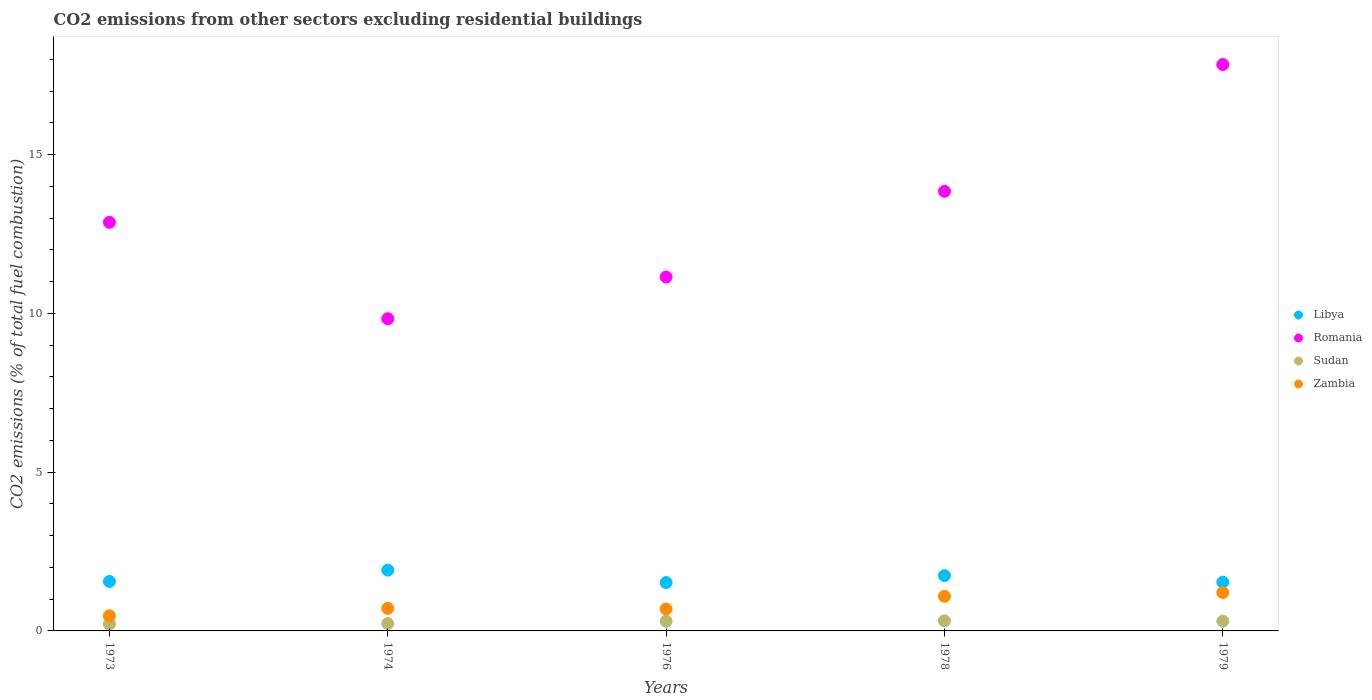What is the total CO2 emitted in Zambia in 1974?
Provide a short and direct response. 0.71. Across all years, what is the maximum total CO2 emitted in Libya?
Keep it short and to the point. 1.91. Across all years, what is the minimum total CO2 emitted in Zambia?
Give a very brief answer. 0.48. In which year was the total CO2 emitted in Romania maximum?
Your response must be concise. 1979. In which year was the total CO2 emitted in Libya minimum?
Your answer should be compact. 1976. What is the total total CO2 emitted in Libya in the graph?
Your answer should be very brief. 8.27. What is the difference between the total CO2 emitted in Romania in 1973 and that in 1978?
Your response must be concise. -0.98. What is the difference between the total CO2 emitted in Zambia in 1978 and the total CO2 emitted in Sudan in 1974?
Keep it short and to the point. 0.86. What is the average total CO2 emitted in Romania per year?
Offer a very short reply. 13.1. In the year 1973, what is the difference between the total CO2 emitted in Libya and total CO2 emitted in Romania?
Give a very brief answer. -11.31. What is the ratio of the total CO2 emitted in Libya in 1976 to that in 1979?
Your answer should be compact. 0.99. Is the difference between the total CO2 emitted in Libya in 1974 and 1976 greater than the difference between the total CO2 emitted in Romania in 1974 and 1976?
Ensure brevity in your answer.  Yes. What is the difference between the highest and the second highest total CO2 emitted in Sudan?
Offer a very short reply. 0.01. What is the difference between the highest and the lowest total CO2 emitted in Zambia?
Your answer should be very brief. 0.73. In how many years, is the total CO2 emitted in Sudan greater than the average total CO2 emitted in Sudan taken over all years?
Your answer should be very brief. 3. Is it the case that in every year, the sum of the total CO2 emitted in Romania and total CO2 emitted in Zambia  is greater than the total CO2 emitted in Libya?
Provide a succinct answer. Yes. Is the total CO2 emitted in Romania strictly greater than the total CO2 emitted in Sudan over the years?
Your answer should be compact. Yes. Are the values on the major ticks of Y-axis written in scientific E-notation?
Provide a short and direct response. No. Does the graph contain grids?
Provide a succinct answer. No. Where does the legend appear in the graph?
Your answer should be very brief. Center right. How are the legend labels stacked?
Give a very brief answer. Vertical. What is the title of the graph?
Keep it short and to the point. CO2 emissions from other sectors excluding residential buildings. Does "Jordan" appear as one of the legend labels in the graph?
Your answer should be very brief. No. What is the label or title of the X-axis?
Offer a very short reply. Years. What is the label or title of the Y-axis?
Your answer should be very brief. CO2 emissions (% of total fuel combustion). What is the CO2 emissions (% of total fuel combustion) in Libya in 1973?
Your response must be concise. 1.56. What is the CO2 emissions (% of total fuel combustion) in Romania in 1973?
Offer a terse response. 12.87. What is the CO2 emissions (% of total fuel combustion) of Sudan in 1973?
Offer a very short reply. 0.22. What is the CO2 emissions (% of total fuel combustion) in Zambia in 1973?
Your answer should be compact. 0.48. What is the CO2 emissions (% of total fuel combustion) of Libya in 1974?
Give a very brief answer. 1.91. What is the CO2 emissions (% of total fuel combustion) in Romania in 1974?
Your answer should be very brief. 9.83. What is the CO2 emissions (% of total fuel combustion) of Sudan in 1974?
Your answer should be compact. 0.23. What is the CO2 emissions (% of total fuel combustion) of Zambia in 1974?
Provide a succinct answer. 0.71. What is the CO2 emissions (% of total fuel combustion) in Libya in 1976?
Provide a succinct answer. 1.52. What is the CO2 emissions (% of total fuel combustion) of Romania in 1976?
Your response must be concise. 11.14. What is the CO2 emissions (% of total fuel combustion) of Sudan in 1976?
Keep it short and to the point. 0.3. What is the CO2 emissions (% of total fuel combustion) in Zambia in 1976?
Provide a short and direct response. 0.69. What is the CO2 emissions (% of total fuel combustion) of Libya in 1978?
Make the answer very short. 1.74. What is the CO2 emissions (% of total fuel combustion) in Romania in 1978?
Keep it short and to the point. 13.84. What is the CO2 emissions (% of total fuel combustion) in Sudan in 1978?
Make the answer very short. 0.32. What is the CO2 emissions (% of total fuel combustion) in Zambia in 1978?
Provide a short and direct response. 1.09. What is the CO2 emissions (% of total fuel combustion) in Libya in 1979?
Give a very brief answer. 1.54. What is the CO2 emissions (% of total fuel combustion) of Romania in 1979?
Your answer should be very brief. 17.83. What is the CO2 emissions (% of total fuel combustion) of Sudan in 1979?
Your response must be concise. 0.31. What is the CO2 emissions (% of total fuel combustion) in Zambia in 1979?
Offer a terse response. 1.21. Across all years, what is the maximum CO2 emissions (% of total fuel combustion) in Libya?
Your answer should be very brief. 1.91. Across all years, what is the maximum CO2 emissions (% of total fuel combustion) in Romania?
Provide a succinct answer. 17.83. Across all years, what is the maximum CO2 emissions (% of total fuel combustion) of Sudan?
Your answer should be very brief. 0.32. Across all years, what is the maximum CO2 emissions (% of total fuel combustion) in Zambia?
Offer a very short reply. 1.21. Across all years, what is the minimum CO2 emissions (% of total fuel combustion) in Libya?
Your answer should be very brief. 1.52. Across all years, what is the minimum CO2 emissions (% of total fuel combustion) in Romania?
Keep it short and to the point. 9.83. Across all years, what is the minimum CO2 emissions (% of total fuel combustion) of Sudan?
Give a very brief answer. 0.22. Across all years, what is the minimum CO2 emissions (% of total fuel combustion) of Zambia?
Make the answer very short. 0.48. What is the total CO2 emissions (% of total fuel combustion) of Libya in the graph?
Give a very brief answer. 8.27. What is the total CO2 emissions (% of total fuel combustion) in Romania in the graph?
Your response must be concise. 65.52. What is the total CO2 emissions (% of total fuel combustion) in Sudan in the graph?
Provide a succinct answer. 1.38. What is the total CO2 emissions (% of total fuel combustion) of Zambia in the graph?
Offer a very short reply. 4.18. What is the difference between the CO2 emissions (% of total fuel combustion) in Libya in 1973 and that in 1974?
Your response must be concise. -0.36. What is the difference between the CO2 emissions (% of total fuel combustion) in Romania in 1973 and that in 1974?
Make the answer very short. 3.03. What is the difference between the CO2 emissions (% of total fuel combustion) in Sudan in 1973 and that in 1974?
Your response must be concise. -0.01. What is the difference between the CO2 emissions (% of total fuel combustion) in Zambia in 1973 and that in 1974?
Make the answer very short. -0.23. What is the difference between the CO2 emissions (% of total fuel combustion) of Libya in 1973 and that in 1976?
Provide a succinct answer. 0.04. What is the difference between the CO2 emissions (% of total fuel combustion) of Romania in 1973 and that in 1976?
Provide a short and direct response. 1.72. What is the difference between the CO2 emissions (% of total fuel combustion) in Sudan in 1973 and that in 1976?
Provide a succinct answer. -0.09. What is the difference between the CO2 emissions (% of total fuel combustion) of Zambia in 1973 and that in 1976?
Offer a very short reply. -0.21. What is the difference between the CO2 emissions (% of total fuel combustion) of Libya in 1973 and that in 1978?
Provide a short and direct response. -0.18. What is the difference between the CO2 emissions (% of total fuel combustion) in Romania in 1973 and that in 1978?
Give a very brief answer. -0.98. What is the difference between the CO2 emissions (% of total fuel combustion) in Sudan in 1973 and that in 1978?
Provide a short and direct response. -0.1. What is the difference between the CO2 emissions (% of total fuel combustion) of Zambia in 1973 and that in 1978?
Your answer should be compact. -0.61. What is the difference between the CO2 emissions (% of total fuel combustion) of Libya in 1973 and that in 1979?
Ensure brevity in your answer.  0.02. What is the difference between the CO2 emissions (% of total fuel combustion) of Romania in 1973 and that in 1979?
Give a very brief answer. -4.97. What is the difference between the CO2 emissions (% of total fuel combustion) in Sudan in 1973 and that in 1979?
Your answer should be very brief. -0.09. What is the difference between the CO2 emissions (% of total fuel combustion) of Zambia in 1973 and that in 1979?
Offer a terse response. -0.73. What is the difference between the CO2 emissions (% of total fuel combustion) of Libya in 1974 and that in 1976?
Your answer should be compact. 0.39. What is the difference between the CO2 emissions (% of total fuel combustion) of Romania in 1974 and that in 1976?
Keep it short and to the point. -1.31. What is the difference between the CO2 emissions (% of total fuel combustion) in Sudan in 1974 and that in 1976?
Offer a very short reply. -0.07. What is the difference between the CO2 emissions (% of total fuel combustion) of Zambia in 1974 and that in 1976?
Your response must be concise. 0.02. What is the difference between the CO2 emissions (% of total fuel combustion) of Libya in 1974 and that in 1978?
Provide a succinct answer. 0.17. What is the difference between the CO2 emissions (% of total fuel combustion) of Romania in 1974 and that in 1978?
Your response must be concise. -4.01. What is the difference between the CO2 emissions (% of total fuel combustion) of Sudan in 1974 and that in 1978?
Ensure brevity in your answer.  -0.09. What is the difference between the CO2 emissions (% of total fuel combustion) in Zambia in 1974 and that in 1978?
Your response must be concise. -0.38. What is the difference between the CO2 emissions (% of total fuel combustion) of Libya in 1974 and that in 1979?
Provide a succinct answer. 0.38. What is the difference between the CO2 emissions (% of total fuel combustion) in Romania in 1974 and that in 1979?
Your answer should be very brief. -8. What is the difference between the CO2 emissions (% of total fuel combustion) in Sudan in 1974 and that in 1979?
Give a very brief answer. -0.08. What is the difference between the CO2 emissions (% of total fuel combustion) in Zambia in 1974 and that in 1979?
Your response must be concise. -0.5. What is the difference between the CO2 emissions (% of total fuel combustion) in Libya in 1976 and that in 1978?
Offer a very short reply. -0.22. What is the difference between the CO2 emissions (% of total fuel combustion) of Romania in 1976 and that in 1978?
Offer a very short reply. -2.7. What is the difference between the CO2 emissions (% of total fuel combustion) of Sudan in 1976 and that in 1978?
Offer a very short reply. -0.01. What is the difference between the CO2 emissions (% of total fuel combustion) of Zambia in 1976 and that in 1978?
Your answer should be very brief. -0.4. What is the difference between the CO2 emissions (% of total fuel combustion) of Libya in 1976 and that in 1979?
Give a very brief answer. -0.01. What is the difference between the CO2 emissions (% of total fuel combustion) of Romania in 1976 and that in 1979?
Offer a very short reply. -6.69. What is the difference between the CO2 emissions (% of total fuel combustion) in Sudan in 1976 and that in 1979?
Offer a terse response. -0. What is the difference between the CO2 emissions (% of total fuel combustion) in Zambia in 1976 and that in 1979?
Your answer should be compact. -0.52. What is the difference between the CO2 emissions (% of total fuel combustion) in Libya in 1978 and that in 1979?
Keep it short and to the point. 0.21. What is the difference between the CO2 emissions (% of total fuel combustion) of Romania in 1978 and that in 1979?
Offer a terse response. -3.99. What is the difference between the CO2 emissions (% of total fuel combustion) of Sudan in 1978 and that in 1979?
Ensure brevity in your answer.  0.01. What is the difference between the CO2 emissions (% of total fuel combustion) of Zambia in 1978 and that in 1979?
Keep it short and to the point. -0.12. What is the difference between the CO2 emissions (% of total fuel combustion) of Libya in 1973 and the CO2 emissions (% of total fuel combustion) of Romania in 1974?
Make the answer very short. -8.27. What is the difference between the CO2 emissions (% of total fuel combustion) of Libya in 1973 and the CO2 emissions (% of total fuel combustion) of Sudan in 1974?
Ensure brevity in your answer.  1.33. What is the difference between the CO2 emissions (% of total fuel combustion) of Libya in 1973 and the CO2 emissions (% of total fuel combustion) of Zambia in 1974?
Your answer should be compact. 0.85. What is the difference between the CO2 emissions (% of total fuel combustion) of Romania in 1973 and the CO2 emissions (% of total fuel combustion) of Sudan in 1974?
Offer a very short reply. 12.63. What is the difference between the CO2 emissions (% of total fuel combustion) of Romania in 1973 and the CO2 emissions (% of total fuel combustion) of Zambia in 1974?
Give a very brief answer. 12.15. What is the difference between the CO2 emissions (% of total fuel combustion) in Sudan in 1973 and the CO2 emissions (% of total fuel combustion) in Zambia in 1974?
Offer a very short reply. -0.49. What is the difference between the CO2 emissions (% of total fuel combustion) in Libya in 1973 and the CO2 emissions (% of total fuel combustion) in Romania in 1976?
Your answer should be compact. -9.59. What is the difference between the CO2 emissions (% of total fuel combustion) of Libya in 1973 and the CO2 emissions (% of total fuel combustion) of Sudan in 1976?
Keep it short and to the point. 1.25. What is the difference between the CO2 emissions (% of total fuel combustion) of Libya in 1973 and the CO2 emissions (% of total fuel combustion) of Zambia in 1976?
Your answer should be very brief. 0.87. What is the difference between the CO2 emissions (% of total fuel combustion) in Romania in 1973 and the CO2 emissions (% of total fuel combustion) in Sudan in 1976?
Provide a short and direct response. 12.56. What is the difference between the CO2 emissions (% of total fuel combustion) of Romania in 1973 and the CO2 emissions (% of total fuel combustion) of Zambia in 1976?
Give a very brief answer. 12.18. What is the difference between the CO2 emissions (% of total fuel combustion) of Sudan in 1973 and the CO2 emissions (% of total fuel combustion) of Zambia in 1976?
Offer a terse response. -0.47. What is the difference between the CO2 emissions (% of total fuel combustion) in Libya in 1973 and the CO2 emissions (% of total fuel combustion) in Romania in 1978?
Your answer should be very brief. -12.29. What is the difference between the CO2 emissions (% of total fuel combustion) of Libya in 1973 and the CO2 emissions (% of total fuel combustion) of Sudan in 1978?
Provide a succinct answer. 1.24. What is the difference between the CO2 emissions (% of total fuel combustion) in Libya in 1973 and the CO2 emissions (% of total fuel combustion) in Zambia in 1978?
Give a very brief answer. 0.47. What is the difference between the CO2 emissions (% of total fuel combustion) of Romania in 1973 and the CO2 emissions (% of total fuel combustion) of Sudan in 1978?
Your answer should be compact. 12.55. What is the difference between the CO2 emissions (% of total fuel combustion) in Romania in 1973 and the CO2 emissions (% of total fuel combustion) in Zambia in 1978?
Give a very brief answer. 11.78. What is the difference between the CO2 emissions (% of total fuel combustion) of Sudan in 1973 and the CO2 emissions (% of total fuel combustion) of Zambia in 1978?
Offer a terse response. -0.87. What is the difference between the CO2 emissions (% of total fuel combustion) in Libya in 1973 and the CO2 emissions (% of total fuel combustion) in Romania in 1979?
Offer a very short reply. -16.28. What is the difference between the CO2 emissions (% of total fuel combustion) of Libya in 1973 and the CO2 emissions (% of total fuel combustion) of Sudan in 1979?
Give a very brief answer. 1.25. What is the difference between the CO2 emissions (% of total fuel combustion) in Libya in 1973 and the CO2 emissions (% of total fuel combustion) in Zambia in 1979?
Your answer should be compact. 0.35. What is the difference between the CO2 emissions (% of total fuel combustion) of Romania in 1973 and the CO2 emissions (% of total fuel combustion) of Sudan in 1979?
Offer a terse response. 12.56. What is the difference between the CO2 emissions (% of total fuel combustion) in Romania in 1973 and the CO2 emissions (% of total fuel combustion) in Zambia in 1979?
Keep it short and to the point. 11.66. What is the difference between the CO2 emissions (% of total fuel combustion) of Sudan in 1973 and the CO2 emissions (% of total fuel combustion) of Zambia in 1979?
Provide a short and direct response. -0.99. What is the difference between the CO2 emissions (% of total fuel combustion) of Libya in 1974 and the CO2 emissions (% of total fuel combustion) of Romania in 1976?
Your answer should be very brief. -9.23. What is the difference between the CO2 emissions (% of total fuel combustion) in Libya in 1974 and the CO2 emissions (% of total fuel combustion) in Sudan in 1976?
Make the answer very short. 1.61. What is the difference between the CO2 emissions (% of total fuel combustion) of Libya in 1974 and the CO2 emissions (% of total fuel combustion) of Zambia in 1976?
Provide a short and direct response. 1.22. What is the difference between the CO2 emissions (% of total fuel combustion) in Romania in 1974 and the CO2 emissions (% of total fuel combustion) in Sudan in 1976?
Make the answer very short. 9.53. What is the difference between the CO2 emissions (% of total fuel combustion) in Romania in 1974 and the CO2 emissions (% of total fuel combustion) in Zambia in 1976?
Make the answer very short. 9.14. What is the difference between the CO2 emissions (% of total fuel combustion) in Sudan in 1974 and the CO2 emissions (% of total fuel combustion) in Zambia in 1976?
Provide a succinct answer. -0.46. What is the difference between the CO2 emissions (% of total fuel combustion) in Libya in 1974 and the CO2 emissions (% of total fuel combustion) in Romania in 1978?
Provide a succinct answer. -11.93. What is the difference between the CO2 emissions (% of total fuel combustion) of Libya in 1974 and the CO2 emissions (% of total fuel combustion) of Sudan in 1978?
Your response must be concise. 1.6. What is the difference between the CO2 emissions (% of total fuel combustion) in Libya in 1974 and the CO2 emissions (% of total fuel combustion) in Zambia in 1978?
Provide a short and direct response. 0.82. What is the difference between the CO2 emissions (% of total fuel combustion) in Romania in 1974 and the CO2 emissions (% of total fuel combustion) in Sudan in 1978?
Make the answer very short. 9.51. What is the difference between the CO2 emissions (% of total fuel combustion) in Romania in 1974 and the CO2 emissions (% of total fuel combustion) in Zambia in 1978?
Provide a short and direct response. 8.74. What is the difference between the CO2 emissions (% of total fuel combustion) in Sudan in 1974 and the CO2 emissions (% of total fuel combustion) in Zambia in 1978?
Give a very brief answer. -0.86. What is the difference between the CO2 emissions (% of total fuel combustion) of Libya in 1974 and the CO2 emissions (% of total fuel combustion) of Romania in 1979?
Your answer should be very brief. -15.92. What is the difference between the CO2 emissions (% of total fuel combustion) in Libya in 1974 and the CO2 emissions (% of total fuel combustion) in Sudan in 1979?
Give a very brief answer. 1.61. What is the difference between the CO2 emissions (% of total fuel combustion) in Libya in 1974 and the CO2 emissions (% of total fuel combustion) in Zambia in 1979?
Your response must be concise. 0.71. What is the difference between the CO2 emissions (% of total fuel combustion) of Romania in 1974 and the CO2 emissions (% of total fuel combustion) of Sudan in 1979?
Ensure brevity in your answer.  9.52. What is the difference between the CO2 emissions (% of total fuel combustion) of Romania in 1974 and the CO2 emissions (% of total fuel combustion) of Zambia in 1979?
Keep it short and to the point. 8.62. What is the difference between the CO2 emissions (% of total fuel combustion) of Sudan in 1974 and the CO2 emissions (% of total fuel combustion) of Zambia in 1979?
Your answer should be compact. -0.98. What is the difference between the CO2 emissions (% of total fuel combustion) of Libya in 1976 and the CO2 emissions (% of total fuel combustion) of Romania in 1978?
Give a very brief answer. -12.32. What is the difference between the CO2 emissions (% of total fuel combustion) of Libya in 1976 and the CO2 emissions (% of total fuel combustion) of Sudan in 1978?
Your response must be concise. 1.21. What is the difference between the CO2 emissions (% of total fuel combustion) in Libya in 1976 and the CO2 emissions (% of total fuel combustion) in Zambia in 1978?
Give a very brief answer. 0.43. What is the difference between the CO2 emissions (% of total fuel combustion) of Romania in 1976 and the CO2 emissions (% of total fuel combustion) of Sudan in 1978?
Provide a short and direct response. 10.83. What is the difference between the CO2 emissions (% of total fuel combustion) of Romania in 1976 and the CO2 emissions (% of total fuel combustion) of Zambia in 1978?
Ensure brevity in your answer.  10.05. What is the difference between the CO2 emissions (% of total fuel combustion) in Sudan in 1976 and the CO2 emissions (% of total fuel combustion) in Zambia in 1978?
Provide a short and direct response. -0.79. What is the difference between the CO2 emissions (% of total fuel combustion) of Libya in 1976 and the CO2 emissions (% of total fuel combustion) of Romania in 1979?
Provide a short and direct response. -16.31. What is the difference between the CO2 emissions (% of total fuel combustion) in Libya in 1976 and the CO2 emissions (% of total fuel combustion) in Sudan in 1979?
Give a very brief answer. 1.21. What is the difference between the CO2 emissions (% of total fuel combustion) of Libya in 1976 and the CO2 emissions (% of total fuel combustion) of Zambia in 1979?
Give a very brief answer. 0.31. What is the difference between the CO2 emissions (% of total fuel combustion) of Romania in 1976 and the CO2 emissions (% of total fuel combustion) of Sudan in 1979?
Ensure brevity in your answer.  10.84. What is the difference between the CO2 emissions (% of total fuel combustion) of Romania in 1976 and the CO2 emissions (% of total fuel combustion) of Zambia in 1979?
Your response must be concise. 9.94. What is the difference between the CO2 emissions (% of total fuel combustion) of Sudan in 1976 and the CO2 emissions (% of total fuel combustion) of Zambia in 1979?
Your response must be concise. -0.9. What is the difference between the CO2 emissions (% of total fuel combustion) in Libya in 1978 and the CO2 emissions (% of total fuel combustion) in Romania in 1979?
Ensure brevity in your answer.  -16.09. What is the difference between the CO2 emissions (% of total fuel combustion) in Libya in 1978 and the CO2 emissions (% of total fuel combustion) in Sudan in 1979?
Your answer should be very brief. 1.43. What is the difference between the CO2 emissions (% of total fuel combustion) of Libya in 1978 and the CO2 emissions (% of total fuel combustion) of Zambia in 1979?
Your response must be concise. 0.53. What is the difference between the CO2 emissions (% of total fuel combustion) of Romania in 1978 and the CO2 emissions (% of total fuel combustion) of Sudan in 1979?
Make the answer very short. 13.53. What is the difference between the CO2 emissions (% of total fuel combustion) in Romania in 1978 and the CO2 emissions (% of total fuel combustion) in Zambia in 1979?
Ensure brevity in your answer.  12.63. What is the difference between the CO2 emissions (% of total fuel combustion) in Sudan in 1978 and the CO2 emissions (% of total fuel combustion) in Zambia in 1979?
Offer a terse response. -0.89. What is the average CO2 emissions (% of total fuel combustion) of Libya per year?
Your answer should be very brief. 1.65. What is the average CO2 emissions (% of total fuel combustion) in Romania per year?
Provide a short and direct response. 13.1. What is the average CO2 emissions (% of total fuel combustion) of Sudan per year?
Ensure brevity in your answer.  0.28. What is the average CO2 emissions (% of total fuel combustion) in Zambia per year?
Provide a succinct answer. 0.84. In the year 1973, what is the difference between the CO2 emissions (% of total fuel combustion) of Libya and CO2 emissions (% of total fuel combustion) of Romania?
Your response must be concise. -11.31. In the year 1973, what is the difference between the CO2 emissions (% of total fuel combustion) in Libya and CO2 emissions (% of total fuel combustion) in Sudan?
Provide a succinct answer. 1.34. In the year 1973, what is the difference between the CO2 emissions (% of total fuel combustion) of Libya and CO2 emissions (% of total fuel combustion) of Zambia?
Your answer should be very brief. 1.08. In the year 1973, what is the difference between the CO2 emissions (% of total fuel combustion) of Romania and CO2 emissions (% of total fuel combustion) of Sudan?
Keep it short and to the point. 12.65. In the year 1973, what is the difference between the CO2 emissions (% of total fuel combustion) of Romania and CO2 emissions (% of total fuel combustion) of Zambia?
Give a very brief answer. 12.39. In the year 1973, what is the difference between the CO2 emissions (% of total fuel combustion) of Sudan and CO2 emissions (% of total fuel combustion) of Zambia?
Your response must be concise. -0.26. In the year 1974, what is the difference between the CO2 emissions (% of total fuel combustion) of Libya and CO2 emissions (% of total fuel combustion) of Romania?
Your response must be concise. -7.92. In the year 1974, what is the difference between the CO2 emissions (% of total fuel combustion) of Libya and CO2 emissions (% of total fuel combustion) of Sudan?
Keep it short and to the point. 1.68. In the year 1974, what is the difference between the CO2 emissions (% of total fuel combustion) of Libya and CO2 emissions (% of total fuel combustion) of Zambia?
Your answer should be very brief. 1.2. In the year 1974, what is the difference between the CO2 emissions (% of total fuel combustion) in Romania and CO2 emissions (% of total fuel combustion) in Sudan?
Offer a terse response. 9.6. In the year 1974, what is the difference between the CO2 emissions (% of total fuel combustion) of Romania and CO2 emissions (% of total fuel combustion) of Zambia?
Ensure brevity in your answer.  9.12. In the year 1974, what is the difference between the CO2 emissions (% of total fuel combustion) of Sudan and CO2 emissions (% of total fuel combustion) of Zambia?
Offer a very short reply. -0.48. In the year 1976, what is the difference between the CO2 emissions (% of total fuel combustion) in Libya and CO2 emissions (% of total fuel combustion) in Romania?
Provide a short and direct response. -9.62. In the year 1976, what is the difference between the CO2 emissions (% of total fuel combustion) in Libya and CO2 emissions (% of total fuel combustion) in Sudan?
Provide a succinct answer. 1.22. In the year 1976, what is the difference between the CO2 emissions (% of total fuel combustion) in Libya and CO2 emissions (% of total fuel combustion) in Zambia?
Make the answer very short. 0.83. In the year 1976, what is the difference between the CO2 emissions (% of total fuel combustion) in Romania and CO2 emissions (% of total fuel combustion) in Sudan?
Your answer should be compact. 10.84. In the year 1976, what is the difference between the CO2 emissions (% of total fuel combustion) in Romania and CO2 emissions (% of total fuel combustion) in Zambia?
Offer a very short reply. 10.45. In the year 1976, what is the difference between the CO2 emissions (% of total fuel combustion) in Sudan and CO2 emissions (% of total fuel combustion) in Zambia?
Offer a terse response. -0.38. In the year 1978, what is the difference between the CO2 emissions (% of total fuel combustion) of Libya and CO2 emissions (% of total fuel combustion) of Romania?
Provide a succinct answer. -12.1. In the year 1978, what is the difference between the CO2 emissions (% of total fuel combustion) of Libya and CO2 emissions (% of total fuel combustion) of Sudan?
Your response must be concise. 1.42. In the year 1978, what is the difference between the CO2 emissions (% of total fuel combustion) in Libya and CO2 emissions (% of total fuel combustion) in Zambia?
Ensure brevity in your answer.  0.65. In the year 1978, what is the difference between the CO2 emissions (% of total fuel combustion) of Romania and CO2 emissions (% of total fuel combustion) of Sudan?
Your answer should be very brief. 13.53. In the year 1978, what is the difference between the CO2 emissions (% of total fuel combustion) in Romania and CO2 emissions (% of total fuel combustion) in Zambia?
Ensure brevity in your answer.  12.75. In the year 1978, what is the difference between the CO2 emissions (% of total fuel combustion) of Sudan and CO2 emissions (% of total fuel combustion) of Zambia?
Offer a terse response. -0.77. In the year 1979, what is the difference between the CO2 emissions (% of total fuel combustion) in Libya and CO2 emissions (% of total fuel combustion) in Romania?
Provide a succinct answer. -16.3. In the year 1979, what is the difference between the CO2 emissions (% of total fuel combustion) of Libya and CO2 emissions (% of total fuel combustion) of Sudan?
Provide a succinct answer. 1.23. In the year 1979, what is the difference between the CO2 emissions (% of total fuel combustion) of Libya and CO2 emissions (% of total fuel combustion) of Zambia?
Your response must be concise. 0.33. In the year 1979, what is the difference between the CO2 emissions (% of total fuel combustion) of Romania and CO2 emissions (% of total fuel combustion) of Sudan?
Offer a very short reply. 17.53. In the year 1979, what is the difference between the CO2 emissions (% of total fuel combustion) in Romania and CO2 emissions (% of total fuel combustion) in Zambia?
Your response must be concise. 16.63. In the year 1979, what is the difference between the CO2 emissions (% of total fuel combustion) of Sudan and CO2 emissions (% of total fuel combustion) of Zambia?
Ensure brevity in your answer.  -0.9. What is the ratio of the CO2 emissions (% of total fuel combustion) in Libya in 1973 to that in 1974?
Offer a terse response. 0.81. What is the ratio of the CO2 emissions (% of total fuel combustion) of Romania in 1973 to that in 1974?
Your answer should be very brief. 1.31. What is the ratio of the CO2 emissions (% of total fuel combustion) in Sudan in 1973 to that in 1974?
Provide a succinct answer. 0.94. What is the ratio of the CO2 emissions (% of total fuel combustion) in Zambia in 1973 to that in 1974?
Provide a short and direct response. 0.67. What is the ratio of the CO2 emissions (% of total fuel combustion) of Libya in 1973 to that in 1976?
Offer a very short reply. 1.02. What is the ratio of the CO2 emissions (% of total fuel combustion) of Romania in 1973 to that in 1976?
Provide a succinct answer. 1.15. What is the ratio of the CO2 emissions (% of total fuel combustion) in Sudan in 1973 to that in 1976?
Provide a short and direct response. 0.71. What is the ratio of the CO2 emissions (% of total fuel combustion) of Zambia in 1973 to that in 1976?
Make the answer very short. 0.69. What is the ratio of the CO2 emissions (% of total fuel combustion) of Libya in 1973 to that in 1978?
Give a very brief answer. 0.89. What is the ratio of the CO2 emissions (% of total fuel combustion) in Romania in 1973 to that in 1978?
Provide a succinct answer. 0.93. What is the ratio of the CO2 emissions (% of total fuel combustion) in Sudan in 1973 to that in 1978?
Your answer should be very brief. 0.69. What is the ratio of the CO2 emissions (% of total fuel combustion) in Zambia in 1973 to that in 1978?
Give a very brief answer. 0.44. What is the ratio of the CO2 emissions (% of total fuel combustion) in Libya in 1973 to that in 1979?
Offer a terse response. 1.01. What is the ratio of the CO2 emissions (% of total fuel combustion) of Romania in 1973 to that in 1979?
Offer a very short reply. 0.72. What is the ratio of the CO2 emissions (% of total fuel combustion) of Sudan in 1973 to that in 1979?
Your response must be concise. 0.7. What is the ratio of the CO2 emissions (% of total fuel combustion) of Zambia in 1973 to that in 1979?
Keep it short and to the point. 0.4. What is the ratio of the CO2 emissions (% of total fuel combustion) in Libya in 1974 to that in 1976?
Offer a very short reply. 1.26. What is the ratio of the CO2 emissions (% of total fuel combustion) of Romania in 1974 to that in 1976?
Give a very brief answer. 0.88. What is the ratio of the CO2 emissions (% of total fuel combustion) in Sudan in 1974 to that in 1976?
Keep it short and to the point. 0.76. What is the ratio of the CO2 emissions (% of total fuel combustion) in Zambia in 1974 to that in 1976?
Offer a terse response. 1.03. What is the ratio of the CO2 emissions (% of total fuel combustion) of Libya in 1974 to that in 1978?
Your answer should be compact. 1.1. What is the ratio of the CO2 emissions (% of total fuel combustion) of Romania in 1974 to that in 1978?
Your response must be concise. 0.71. What is the ratio of the CO2 emissions (% of total fuel combustion) of Sudan in 1974 to that in 1978?
Your answer should be very brief. 0.73. What is the ratio of the CO2 emissions (% of total fuel combustion) in Zambia in 1974 to that in 1978?
Offer a terse response. 0.65. What is the ratio of the CO2 emissions (% of total fuel combustion) of Libya in 1974 to that in 1979?
Your answer should be compact. 1.25. What is the ratio of the CO2 emissions (% of total fuel combustion) of Romania in 1974 to that in 1979?
Give a very brief answer. 0.55. What is the ratio of the CO2 emissions (% of total fuel combustion) of Sudan in 1974 to that in 1979?
Keep it short and to the point. 0.75. What is the ratio of the CO2 emissions (% of total fuel combustion) of Zambia in 1974 to that in 1979?
Offer a terse response. 0.59. What is the ratio of the CO2 emissions (% of total fuel combustion) in Libya in 1976 to that in 1978?
Offer a very short reply. 0.87. What is the ratio of the CO2 emissions (% of total fuel combustion) in Romania in 1976 to that in 1978?
Offer a terse response. 0.81. What is the ratio of the CO2 emissions (% of total fuel combustion) in Sudan in 1976 to that in 1978?
Your response must be concise. 0.96. What is the ratio of the CO2 emissions (% of total fuel combustion) of Zambia in 1976 to that in 1978?
Provide a short and direct response. 0.63. What is the ratio of the CO2 emissions (% of total fuel combustion) of Romania in 1976 to that in 1979?
Offer a very short reply. 0.62. What is the ratio of the CO2 emissions (% of total fuel combustion) in Zambia in 1976 to that in 1979?
Provide a succinct answer. 0.57. What is the ratio of the CO2 emissions (% of total fuel combustion) in Libya in 1978 to that in 1979?
Provide a short and direct response. 1.13. What is the ratio of the CO2 emissions (% of total fuel combustion) of Romania in 1978 to that in 1979?
Offer a very short reply. 0.78. What is the ratio of the CO2 emissions (% of total fuel combustion) of Sudan in 1978 to that in 1979?
Make the answer very short. 1.03. What is the ratio of the CO2 emissions (% of total fuel combustion) of Zambia in 1978 to that in 1979?
Give a very brief answer. 0.9. What is the difference between the highest and the second highest CO2 emissions (% of total fuel combustion) of Libya?
Make the answer very short. 0.17. What is the difference between the highest and the second highest CO2 emissions (% of total fuel combustion) in Romania?
Provide a succinct answer. 3.99. What is the difference between the highest and the second highest CO2 emissions (% of total fuel combustion) in Sudan?
Make the answer very short. 0.01. What is the difference between the highest and the second highest CO2 emissions (% of total fuel combustion) of Zambia?
Provide a short and direct response. 0.12. What is the difference between the highest and the lowest CO2 emissions (% of total fuel combustion) in Libya?
Your response must be concise. 0.39. What is the difference between the highest and the lowest CO2 emissions (% of total fuel combustion) of Romania?
Your answer should be very brief. 8. What is the difference between the highest and the lowest CO2 emissions (% of total fuel combustion) in Sudan?
Keep it short and to the point. 0.1. What is the difference between the highest and the lowest CO2 emissions (% of total fuel combustion) in Zambia?
Your answer should be compact. 0.73. 